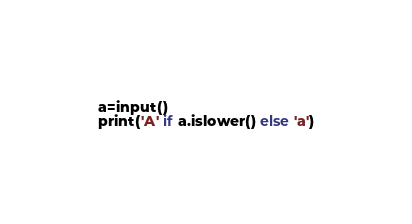Convert code to text. <code><loc_0><loc_0><loc_500><loc_500><_Python_>a=input()
print('A' if a.islower() else 'a')</code> 